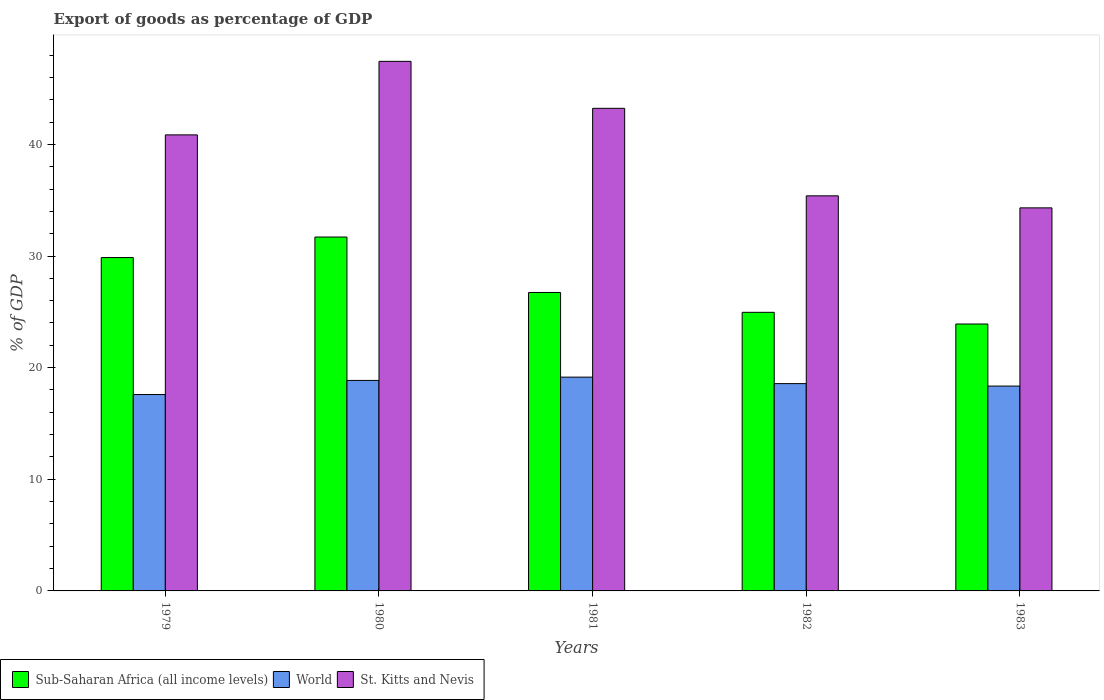How many groups of bars are there?
Your answer should be compact. 5. Are the number of bars per tick equal to the number of legend labels?
Make the answer very short. Yes. Are the number of bars on each tick of the X-axis equal?
Ensure brevity in your answer.  Yes. How many bars are there on the 2nd tick from the right?
Provide a short and direct response. 3. What is the label of the 3rd group of bars from the left?
Keep it short and to the point. 1981. In how many cases, is the number of bars for a given year not equal to the number of legend labels?
Ensure brevity in your answer.  0. What is the export of goods as percentage of GDP in Sub-Saharan Africa (all income levels) in 1981?
Make the answer very short. 26.73. Across all years, what is the maximum export of goods as percentage of GDP in Sub-Saharan Africa (all income levels)?
Give a very brief answer. 31.7. Across all years, what is the minimum export of goods as percentage of GDP in World?
Give a very brief answer. 17.59. In which year was the export of goods as percentage of GDP in Sub-Saharan Africa (all income levels) minimum?
Offer a terse response. 1983. What is the total export of goods as percentage of GDP in Sub-Saharan Africa (all income levels) in the graph?
Your answer should be very brief. 137.16. What is the difference between the export of goods as percentage of GDP in World in 1980 and that in 1982?
Your answer should be compact. 0.29. What is the difference between the export of goods as percentage of GDP in Sub-Saharan Africa (all income levels) in 1981 and the export of goods as percentage of GDP in World in 1980?
Provide a short and direct response. 7.88. What is the average export of goods as percentage of GDP in World per year?
Offer a very short reply. 18.5. In the year 1981, what is the difference between the export of goods as percentage of GDP in World and export of goods as percentage of GDP in St. Kitts and Nevis?
Your answer should be very brief. -24.08. In how many years, is the export of goods as percentage of GDP in World greater than 34 %?
Give a very brief answer. 0. What is the ratio of the export of goods as percentage of GDP in World in 1979 to that in 1983?
Offer a very short reply. 0.96. Is the export of goods as percentage of GDP in Sub-Saharan Africa (all income levels) in 1979 less than that in 1983?
Keep it short and to the point. No. Is the difference between the export of goods as percentage of GDP in World in 1981 and 1982 greater than the difference between the export of goods as percentage of GDP in St. Kitts and Nevis in 1981 and 1982?
Ensure brevity in your answer.  No. What is the difference between the highest and the second highest export of goods as percentage of GDP in World?
Give a very brief answer. 0.3. What is the difference between the highest and the lowest export of goods as percentage of GDP in St. Kitts and Nevis?
Provide a succinct answer. 13.12. In how many years, is the export of goods as percentage of GDP in St. Kitts and Nevis greater than the average export of goods as percentage of GDP in St. Kitts and Nevis taken over all years?
Give a very brief answer. 3. Is the sum of the export of goods as percentage of GDP in St. Kitts and Nevis in 1979 and 1983 greater than the maximum export of goods as percentage of GDP in Sub-Saharan Africa (all income levels) across all years?
Your response must be concise. Yes. What does the 3rd bar from the right in 1981 represents?
Your response must be concise. Sub-Saharan Africa (all income levels). How many years are there in the graph?
Give a very brief answer. 5. What is the difference between two consecutive major ticks on the Y-axis?
Your response must be concise. 10. Does the graph contain any zero values?
Provide a short and direct response. No. Does the graph contain grids?
Your response must be concise. No. Where does the legend appear in the graph?
Ensure brevity in your answer.  Bottom left. How are the legend labels stacked?
Offer a terse response. Horizontal. What is the title of the graph?
Offer a very short reply. Export of goods as percentage of GDP. Does "Middle income" appear as one of the legend labels in the graph?
Provide a short and direct response. No. What is the label or title of the Y-axis?
Ensure brevity in your answer.  % of GDP. What is the % of GDP in Sub-Saharan Africa (all income levels) in 1979?
Offer a very short reply. 29.86. What is the % of GDP in World in 1979?
Provide a short and direct response. 17.59. What is the % of GDP of St. Kitts and Nevis in 1979?
Your answer should be compact. 40.85. What is the % of GDP of Sub-Saharan Africa (all income levels) in 1980?
Provide a succinct answer. 31.7. What is the % of GDP in World in 1980?
Make the answer very short. 18.86. What is the % of GDP in St. Kitts and Nevis in 1980?
Your answer should be compact. 47.44. What is the % of GDP in Sub-Saharan Africa (all income levels) in 1981?
Provide a short and direct response. 26.73. What is the % of GDP of World in 1981?
Offer a very short reply. 19.15. What is the % of GDP in St. Kitts and Nevis in 1981?
Provide a short and direct response. 43.23. What is the % of GDP in Sub-Saharan Africa (all income levels) in 1982?
Give a very brief answer. 24.96. What is the % of GDP of World in 1982?
Your response must be concise. 18.57. What is the % of GDP of St. Kitts and Nevis in 1982?
Give a very brief answer. 35.39. What is the % of GDP of Sub-Saharan Africa (all income levels) in 1983?
Your answer should be very brief. 23.91. What is the % of GDP of World in 1983?
Make the answer very short. 18.35. What is the % of GDP of St. Kitts and Nevis in 1983?
Ensure brevity in your answer.  34.31. Across all years, what is the maximum % of GDP in Sub-Saharan Africa (all income levels)?
Ensure brevity in your answer.  31.7. Across all years, what is the maximum % of GDP in World?
Your response must be concise. 19.15. Across all years, what is the maximum % of GDP of St. Kitts and Nevis?
Provide a succinct answer. 47.44. Across all years, what is the minimum % of GDP of Sub-Saharan Africa (all income levels)?
Your response must be concise. 23.91. Across all years, what is the minimum % of GDP of World?
Provide a succinct answer. 17.59. Across all years, what is the minimum % of GDP of St. Kitts and Nevis?
Your response must be concise. 34.31. What is the total % of GDP in Sub-Saharan Africa (all income levels) in the graph?
Your answer should be very brief. 137.16. What is the total % of GDP in World in the graph?
Provide a short and direct response. 92.52. What is the total % of GDP in St. Kitts and Nevis in the graph?
Your response must be concise. 201.22. What is the difference between the % of GDP of Sub-Saharan Africa (all income levels) in 1979 and that in 1980?
Keep it short and to the point. -1.84. What is the difference between the % of GDP in World in 1979 and that in 1980?
Offer a very short reply. -1.26. What is the difference between the % of GDP in St. Kitts and Nevis in 1979 and that in 1980?
Your response must be concise. -6.59. What is the difference between the % of GDP of Sub-Saharan Africa (all income levels) in 1979 and that in 1981?
Your answer should be very brief. 3.13. What is the difference between the % of GDP in World in 1979 and that in 1981?
Your answer should be compact. -1.56. What is the difference between the % of GDP in St. Kitts and Nevis in 1979 and that in 1981?
Your response must be concise. -2.38. What is the difference between the % of GDP of Sub-Saharan Africa (all income levels) in 1979 and that in 1982?
Provide a short and direct response. 4.91. What is the difference between the % of GDP of World in 1979 and that in 1982?
Offer a terse response. -0.98. What is the difference between the % of GDP in St. Kitts and Nevis in 1979 and that in 1982?
Your answer should be very brief. 5.46. What is the difference between the % of GDP of Sub-Saharan Africa (all income levels) in 1979 and that in 1983?
Your answer should be very brief. 5.95. What is the difference between the % of GDP in World in 1979 and that in 1983?
Your answer should be compact. -0.76. What is the difference between the % of GDP in St. Kitts and Nevis in 1979 and that in 1983?
Your answer should be very brief. 6.54. What is the difference between the % of GDP of Sub-Saharan Africa (all income levels) in 1980 and that in 1981?
Provide a succinct answer. 4.97. What is the difference between the % of GDP of World in 1980 and that in 1981?
Provide a short and direct response. -0.3. What is the difference between the % of GDP in St. Kitts and Nevis in 1980 and that in 1981?
Keep it short and to the point. 4.21. What is the difference between the % of GDP of Sub-Saharan Africa (all income levels) in 1980 and that in 1982?
Your answer should be very brief. 6.74. What is the difference between the % of GDP of World in 1980 and that in 1982?
Ensure brevity in your answer.  0.29. What is the difference between the % of GDP in St. Kitts and Nevis in 1980 and that in 1982?
Make the answer very short. 12.05. What is the difference between the % of GDP of Sub-Saharan Africa (all income levels) in 1980 and that in 1983?
Provide a short and direct response. 7.79. What is the difference between the % of GDP of World in 1980 and that in 1983?
Provide a succinct answer. 0.51. What is the difference between the % of GDP in St. Kitts and Nevis in 1980 and that in 1983?
Make the answer very short. 13.12. What is the difference between the % of GDP of Sub-Saharan Africa (all income levels) in 1981 and that in 1982?
Keep it short and to the point. 1.78. What is the difference between the % of GDP in World in 1981 and that in 1982?
Your response must be concise. 0.58. What is the difference between the % of GDP in St. Kitts and Nevis in 1981 and that in 1982?
Your answer should be very brief. 7.84. What is the difference between the % of GDP in Sub-Saharan Africa (all income levels) in 1981 and that in 1983?
Make the answer very short. 2.82. What is the difference between the % of GDP of World in 1981 and that in 1983?
Your answer should be compact. 0.8. What is the difference between the % of GDP of St. Kitts and Nevis in 1981 and that in 1983?
Your answer should be compact. 8.92. What is the difference between the % of GDP of Sub-Saharan Africa (all income levels) in 1982 and that in 1983?
Offer a terse response. 1.05. What is the difference between the % of GDP in World in 1982 and that in 1983?
Provide a succinct answer. 0.22. What is the difference between the % of GDP in St. Kitts and Nevis in 1982 and that in 1983?
Your answer should be very brief. 1.08. What is the difference between the % of GDP in Sub-Saharan Africa (all income levels) in 1979 and the % of GDP in World in 1980?
Keep it short and to the point. 11.01. What is the difference between the % of GDP of Sub-Saharan Africa (all income levels) in 1979 and the % of GDP of St. Kitts and Nevis in 1980?
Ensure brevity in your answer.  -17.57. What is the difference between the % of GDP in World in 1979 and the % of GDP in St. Kitts and Nevis in 1980?
Offer a terse response. -29.84. What is the difference between the % of GDP of Sub-Saharan Africa (all income levels) in 1979 and the % of GDP of World in 1981?
Provide a short and direct response. 10.71. What is the difference between the % of GDP of Sub-Saharan Africa (all income levels) in 1979 and the % of GDP of St. Kitts and Nevis in 1981?
Give a very brief answer. -13.37. What is the difference between the % of GDP in World in 1979 and the % of GDP in St. Kitts and Nevis in 1981?
Your response must be concise. -25.64. What is the difference between the % of GDP in Sub-Saharan Africa (all income levels) in 1979 and the % of GDP in World in 1982?
Make the answer very short. 11.29. What is the difference between the % of GDP in Sub-Saharan Africa (all income levels) in 1979 and the % of GDP in St. Kitts and Nevis in 1982?
Give a very brief answer. -5.53. What is the difference between the % of GDP of World in 1979 and the % of GDP of St. Kitts and Nevis in 1982?
Provide a short and direct response. -17.8. What is the difference between the % of GDP in Sub-Saharan Africa (all income levels) in 1979 and the % of GDP in World in 1983?
Your response must be concise. 11.51. What is the difference between the % of GDP of Sub-Saharan Africa (all income levels) in 1979 and the % of GDP of St. Kitts and Nevis in 1983?
Keep it short and to the point. -4.45. What is the difference between the % of GDP of World in 1979 and the % of GDP of St. Kitts and Nevis in 1983?
Your answer should be very brief. -16.72. What is the difference between the % of GDP of Sub-Saharan Africa (all income levels) in 1980 and the % of GDP of World in 1981?
Your answer should be compact. 12.55. What is the difference between the % of GDP of Sub-Saharan Africa (all income levels) in 1980 and the % of GDP of St. Kitts and Nevis in 1981?
Make the answer very short. -11.53. What is the difference between the % of GDP in World in 1980 and the % of GDP in St. Kitts and Nevis in 1981?
Provide a succinct answer. -24.37. What is the difference between the % of GDP of Sub-Saharan Africa (all income levels) in 1980 and the % of GDP of World in 1982?
Ensure brevity in your answer.  13.13. What is the difference between the % of GDP of Sub-Saharan Africa (all income levels) in 1980 and the % of GDP of St. Kitts and Nevis in 1982?
Your answer should be compact. -3.69. What is the difference between the % of GDP in World in 1980 and the % of GDP in St. Kitts and Nevis in 1982?
Your answer should be very brief. -16.54. What is the difference between the % of GDP in Sub-Saharan Africa (all income levels) in 1980 and the % of GDP in World in 1983?
Your answer should be very brief. 13.35. What is the difference between the % of GDP of Sub-Saharan Africa (all income levels) in 1980 and the % of GDP of St. Kitts and Nevis in 1983?
Provide a succinct answer. -2.61. What is the difference between the % of GDP in World in 1980 and the % of GDP in St. Kitts and Nevis in 1983?
Ensure brevity in your answer.  -15.46. What is the difference between the % of GDP of Sub-Saharan Africa (all income levels) in 1981 and the % of GDP of World in 1982?
Your answer should be very brief. 8.16. What is the difference between the % of GDP in Sub-Saharan Africa (all income levels) in 1981 and the % of GDP in St. Kitts and Nevis in 1982?
Ensure brevity in your answer.  -8.66. What is the difference between the % of GDP in World in 1981 and the % of GDP in St. Kitts and Nevis in 1982?
Provide a short and direct response. -16.24. What is the difference between the % of GDP in Sub-Saharan Africa (all income levels) in 1981 and the % of GDP in World in 1983?
Provide a succinct answer. 8.38. What is the difference between the % of GDP of Sub-Saharan Africa (all income levels) in 1981 and the % of GDP of St. Kitts and Nevis in 1983?
Keep it short and to the point. -7.58. What is the difference between the % of GDP of World in 1981 and the % of GDP of St. Kitts and Nevis in 1983?
Your answer should be very brief. -15.16. What is the difference between the % of GDP in Sub-Saharan Africa (all income levels) in 1982 and the % of GDP in World in 1983?
Offer a terse response. 6.61. What is the difference between the % of GDP in Sub-Saharan Africa (all income levels) in 1982 and the % of GDP in St. Kitts and Nevis in 1983?
Your answer should be very brief. -9.36. What is the difference between the % of GDP in World in 1982 and the % of GDP in St. Kitts and Nevis in 1983?
Provide a succinct answer. -15.74. What is the average % of GDP in Sub-Saharan Africa (all income levels) per year?
Keep it short and to the point. 27.43. What is the average % of GDP in World per year?
Your answer should be very brief. 18.5. What is the average % of GDP in St. Kitts and Nevis per year?
Provide a short and direct response. 40.24. In the year 1979, what is the difference between the % of GDP of Sub-Saharan Africa (all income levels) and % of GDP of World?
Your answer should be compact. 12.27. In the year 1979, what is the difference between the % of GDP of Sub-Saharan Africa (all income levels) and % of GDP of St. Kitts and Nevis?
Provide a succinct answer. -10.99. In the year 1979, what is the difference between the % of GDP of World and % of GDP of St. Kitts and Nevis?
Provide a short and direct response. -23.26. In the year 1980, what is the difference between the % of GDP in Sub-Saharan Africa (all income levels) and % of GDP in World?
Ensure brevity in your answer.  12.84. In the year 1980, what is the difference between the % of GDP of Sub-Saharan Africa (all income levels) and % of GDP of St. Kitts and Nevis?
Provide a succinct answer. -15.74. In the year 1980, what is the difference between the % of GDP of World and % of GDP of St. Kitts and Nevis?
Offer a very short reply. -28.58. In the year 1981, what is the difference between the % of GDP of Sub-Saharan Africa (all income levels) and % of GDP of World?
Provide a succinct answer. 7.58. In the year 1981, what is the difference between the % of GDP in Sub-Saharan Africa (all income levels) and % of GDP in St. Kitts and Nevis?
Keep it short and to the point. -16.5. In the year 1981, what is the difference between the % of GDP of World and % of GDP of St. Kitts and Nevis?
Provide a succinct answer. -24.08. In the year 1982, what is the difference between the % of GDP of Sub-Saharan Africa (all income levels) and % of GDP of World?
Your response must be concise. 6.39. In the year 1982, what is the difference between the % of GDP in Sub-Saharan Africa (all income levels) and % of GDP in St. Kitts and Nevis?
Keep it short and to the point. -10.43. In the year 1982, what is the difference between the % of GDP in World and % of GDP in St. Kitts and Nevis?
Provide a succinct answer. -16.82. In the year 1983, what is the difference between the % of GDP of Sub-Saharan Africa (all income levels) and % of GDP of World?
Keep it short and to the point. 5.56. In the year 1983, what is the difference between the % of GDP of Sub-Saharan Africa (all income levels) and % of GDP of St. Kitts and Nevis?
Provide a short and direct response. -10.4. In the year 1983, what is the difference between the % of GDP of World and % of GDP of St. Kitts and Nevis?
Give a very brief answer. -15.96. What is the ratio of the % of GDP of Sub-Saharan Africa (all income levels) in 1979 to that in 1980?
Your answer should be very brief. 0.94. What is the ratio of the % of GDP in World in 1979 to that in 1980?
Your answer should be very brief. 0.93. What is the ratio of the % of GDP in St. Kitts and Nevis in 1979 to that in 1980?
Ensure brevity in your answer.  0.86. What is the ratio of the % of GDP in Sub-Saharan Africa (all income levels) in 1979 to that in 1981?
Your response must be concise. 1.12. What is the ratio of the % of GDP in World in 1979 to that in 1981?
Offer a very short reply. 0.92. What is the ratio of the % of GDP of St. Kitts and Nevis in 1979 to that in 1981?
Provide a succinct answer. 0.94. What is the ratio of the % of GDP of Sub-Saharan Africa (all income levels) in 1979 to that in 1982?
Provide a succinct answer. 1.2. What is the ratio of the % of GDP in St. Kitts and Nevis in 1979 to that in 1982?
Keep it short and to the point. 1.15. What is the ratio of the % of GDP of Sub-Saharan Africa (all income levels) in 1979 to that in 1983?
Your answer should be compact. 1.25. What is the ratio of the % of GDP in World in 1979 to that in 1983?
Offer a very short reply. 0.96. What is the ratio of the % of GDP in St. Kitts and Nevis in 1979 to that in 1983?
Your answer should be very brief. 1.19. What is the ratio of the % of GDP of Sub-Saharan Africa (all income levels) in 1980 to that in 1981?
Give a very brief answer. 1.19. What is the ratio of the % of GDP in World in 1980 to that in 1981?
Provide a short and direct response. 0.98. What is the ratio of the % of GDP in St. Kitts and Nevis in 1980 to that in 1981?
Offer a very short reply. 1.1. What is the ratio of the % of GDP in Sub-Saharan Africa (all income levels) in 1980 to that in 1982?
Make the answer very short. 1.27. What is the ratio of the % of GDP in World in 1980 to that in 1982?
Your answer should be compact. 1.02. What is the ratio of the % of GDP of St. Kitts and Nevis in 1980 to that in 1982?
Offer a very short reply. 1.34. What is the ratio of the % of GDP in Sub-Saharan Africa (all income levels) in 1980 to that in 1983?
Keep it short and to the point. 1.33. What is the ratio of the % of GDP of World in 1980 to that in 1983?
Keep it short and to the point. 1.03. What is the ratio of the % of GDP in St. Kitts and Nevis in 1980 to that in 1983?
Provide a short and direct response. 1.38. What is the ratio of the % of GDP of Sub-Saharan Africa (all income levels) in 1981 to that in 1982?
Your answer should be very brief. 1.07. What is the ratio of the % of GDP of World in 1981 to that in 1982?
Your answer should be compact. 1.03. What is the ratio of the % of GDP in St. Kitts and Nevis in 1981 to that in 1982?
Your response must be concise. 1.22. What is the ratio of the % of GDP in Sub-Saharan Africa (all income levels) in 1981 to that in 1983?
Make the answer very short. 1.12. What is the ratio of the % of GDP of World in 1981 to that in 1983?
Offer a terse response. 1.04. What is the ratio of the % of GDP of St. Kitts and Nevis in 1981 to that in 1983?
Offer a very short reply. 1.26. What is the ratio of the % of GDP in Sub-Saharan Africa (all income levels) in 1982 to that in 1983?
Your answer should be very brief. 1.04. What is the ratio of the % of GDP in St. Kitts and Nevis in 1982 to that in 1983?
Provide a short and direct response. 1.03. What is the difference between the highest and the second highest % of GDP of Sub-Saharan Africa (all income levels)?
Your answer should be compact. 1.84. What is the difference between the highest and the second highest % of GDP in World?
Your answer should be compact. 0.3. What is the difference between the highest and the second highest % of GDP of St. Kitts and Nevis?
Offer a very short reply. 4.21. What is the difference between the highest and the lowest % of GDP in Sub-Saharan Africa (all income levels)?
Offer a very short reply. 7.79. What is the difference between the highest and the lowest % of GDP of World?
Offer a very short reply. 1.56. What is the difference between the highest and the lowest % of GDP of St. Kitts and Nevis?
Offer a terse response. 13.12. 